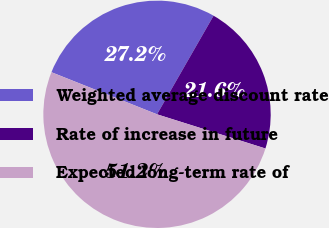Convert chart to OTSL. <chart><loc_0><loc_0><loc_500><loc_500><pie_chart><fcel>Weighted average discount rate<fcel>Rate of increase in future<fcel>Expected long-term rate of<nl><fcel>27.25%<fcel>21.57%<fcel>51.18%<nl></chart> 